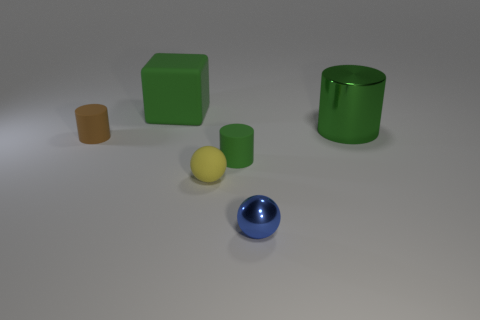Can you tell me what the various objects are and their colors in this image? Certainly! In the image, there are five objects. Starting from the left, there's a small, brown rectangular prism, a small yellow cylinder, a large green cube, a smaller green cylinder, and a small blue sphere. The background is a neutral gray, which provides a nice contrast to the objects' colors. 